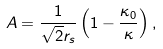<formula> <loc_0><loc_0><loc_500><loc_500>A = \frac { 1 } { \sqrt { 2 } r _ { s } } \left ( 1 - \frac { \kappa _ { 0 } } { \kappa } \right ) ,</formula> 